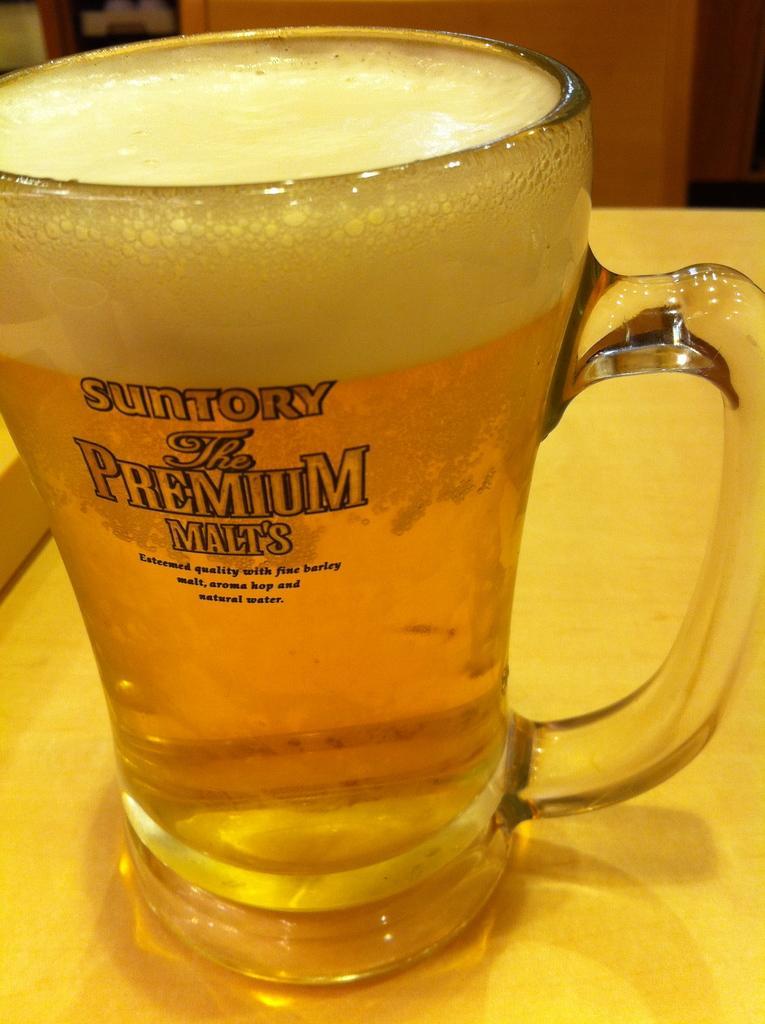Please provide a concise description of this image. There is a glass containing beer on the table. 